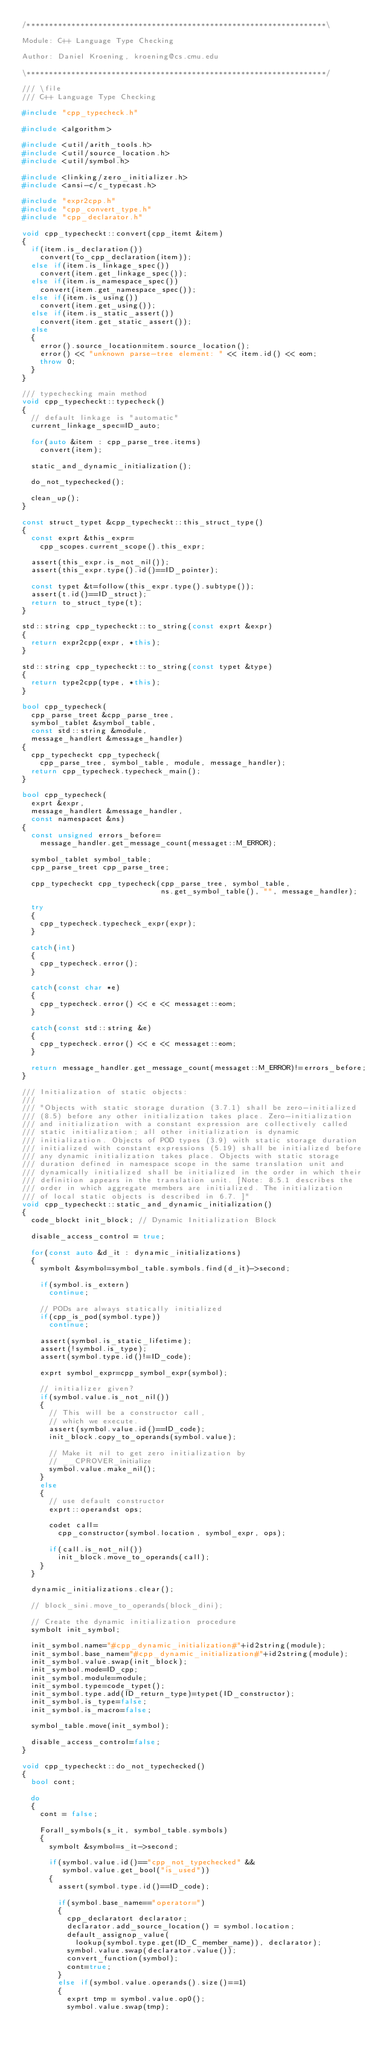<code> <loc_0><loc_0><loc_500><loc_500><_C++_>/*******************************************************************\

Module: C++ Language Type Checking

Author: Daniel Kroening, kroening@cs.cmu.edu

\*******************************************************************/

/// \file
/// C++ Language Type Checking

#include "cpp_typecheck.h"

#include <algorithm>

#include <util/arith_tools.h>
#include <util/source_location.h>
#include <util/symbol.h>

#include <linking/zero_initializer.h>
#include <ansi-c/c_typecast.h>

#include "expr2cpp.h"
#include "cpp_convert_type.h"
#include "cpp_declarator.h"

void cpp_typecheckt::convert(cpp_itemt &item)
{
  if(item.is_declaration())
    convert(to_cpp_declaration(item));
  else if(item.is_linkage_spec())
    convert(item.get_linkage_spec());
  else if(item.is_namespace_spec())
    convert(item.get_namespace_spec());
  else if(item.is_using())
    convert(item.get_using());
  else if(item.is_static_assert())
    convert(item.get_static_assert());
  else
  {
    error().source_location=item.source_location();
    error() << "unknown parse-tree element: " << item.id() << eom;
    throw 0;
  }
}

/// typechecking main method
void cpp_typecheckt::typecheck()
{
  // default linkage is "automatic"
  current_linkage_spec=ID_auto;

  for(auto &item : cpp_parse_tree.items)
    convert(item);

  static_and_dynamic_initialization();

  do_not_typechecked();

  clean_up();
}

const struct_typet &cpp_typecheckt::this_struct_type()
{
  const exprt &this_expr=
    cpp_scopes.current_scope().this_expr;

  assert(this_expr.is_not_nil());
  assert(this_expr.type().id()==ID_pointer);

  const typet &t=follow(this_expr.type().subtype());
  assert(t.id()==ID_struct);
  return to_struct_type(t);
}

std::string cpp_typecheckt::to_string(const exprt &expr)
{
  return expr2cpp(expr, *this);
}

std::string cpp_typecheckt::to_string(const typet &type)
{
  return type2cpp(type, *this);
}

bool cpp_typecheck(
  cpp_parse_treet &cpp_parse_tree,
  symbol_tablet &symbol_table,
  const std::string &module,
  message_handlert &message_handler)
{
  cpp_typecheckt cpp_typecheck(
    cpp_parse_tree, symbol_table, module, message_handler);
  return cpp_typecheck.typecheck_main();
}

bool cpp_typecheck(
  exprt &expr,
  message_handlert &message_handler,
  const namespacet &ns)
{
  const unsigned errors_before=
    message_handler.get_message_count(messaget::M_ERROR);

  symbol_tablet symbol_table;
  cpp_parse_treet cpp_parse_tree;

  cpp_typecheckt cpp_typecheck(cpp_parse_tree, symbol_table,
                               ns.get_symbol_table(), "", message_handler);

  try
  {
    cpp_typecheck.typecheck_expr(expr);
  }

  catch(int)
  {
    cpp_typecheck.error();
  }

  catch(const char *e)
  {
    cpp_typecheck.error() << e << messaget::eom;
  }

  catch(const std::string &e)
  {
    cpp_typecheck.error() << e << messaget::eom;
  }

  return message_handler.get_message_count(messaget::M_ERROR)!=errors_before;
}

/// Initialization of static objects:
///
/// "Objects with static storage duration (3.7.1) shall be zero-initialized
/// (8.5) before any other initialization takes place. Zero-initialization
/// and initialization with a constant expression are collectively called
/// static initialization; all other initialization is dynamic
/// initialization. Objects of POD types (3.9) with static storage duration
/// initialized with constant expressions (5.19) shall be initialized before
/// any dynamic initialization takes place. Objects with static storage
/// duration defined in namespace scope in the same translation unit and
/// dynamically initialized shall be initialized in the order in which their
/// definition appears in the translation unit. [Note: 8.5.1 describes the
/// order in which aggregate members are initialized. The initialization
/// of local static objects is described in 6.7. ]"
void cpp_typecheckt::static_and_dynamic_initialization()
{
  code_blockt init_block; // Dynamic Initialization Block

  disable_access_control = true;

  for(const auto &d_it : dynamic_initializations)
  {
    symbolt &symbol=symbol_table.symbols.find(d_it)->second;

    if(symbol.is_extern)
      continue;

    // PODs are always statically initialized
    if(cpp_is_pod(symbol.type))
      continue;

    assert(symbol.is_static_lifetime);
    assert(!symbol.is_type);
    assert(symbol.type.id()!=ID_code);

    exprt symbol_expr=cpp_symbol_expr(symbol);

    // initializer given?
    if(symbol.value.is_not_nil())
    {
      // This will be a constructor call,
      // which we execute.
      assert(symbol.value.id()==ID_code);
      init_block.copy_to_operands(symbol.value);

      // Make it nil to get zero initialization by
      // __CPROVER_initialize
      symbol.value.make_nil();
    }
    else
    {
      // use default constructor
      exprt::operandst ops;

      codet call=
        cpp_constructor(symbol.location, symbol_expr, ops);

      if(call.is_not_nil())
        init_block.move_to_operands(call);
    }
  }

  dynamic_initializations.clear();

  // block_sini.move_to_operands(block_dini);

  // Create the dynamic initialization procedure
  symbolt init_symbol;

  init_symbol.name="#cpp_dynamic_initialization#"+id2string(module);
  init_symbol.base_name="#cpp_dynamic_initialization#"+id2string(module);
  init_symbol.value.swap(init_block);
  init_symbol.mode=ID_cpp;
  init_symbol.module=module;
  init_symbol.type=code_typet();
  init_symbol.type.add(ID_return_type)=typet(ID_constructor);
  init_symbol.is_type=false;
  init_symbol.is_macro=false;

  symbol_table.move(init_symbol);

  disable_access_control=false;
}

void cpp_typecheckt::do_not_typechecked()
{
  bool cont;

  do
  {
    cont = false;

    Forall_symbols(s_it, symbol_table.symbols)
    {
      symbolt &symbol=s_it->second;

      if(symbol.value.id()=="cpp_not_typechecked" &&
         symbol.value.get_bool("is_used"))
      {
        assert(symbol.type.id()==ID_code);

        if(symbol.base_name=="operator=")
        {
          cpp_declaratort declarator;
          declarator.add_source_location() = symbol.location;
          default_assignop_value(
            lookup(symbol.type.get(ID_C_member_name)), declarator);
          symbol.value.swap(declarator.value());
          convert_function(symbol);
          cont=true;
        }
        else if(symbol.value.operands().size()==1)
        {
          exprt tmp = symbol.value.op0();
          symbol.value.swap(tmp);</code> 